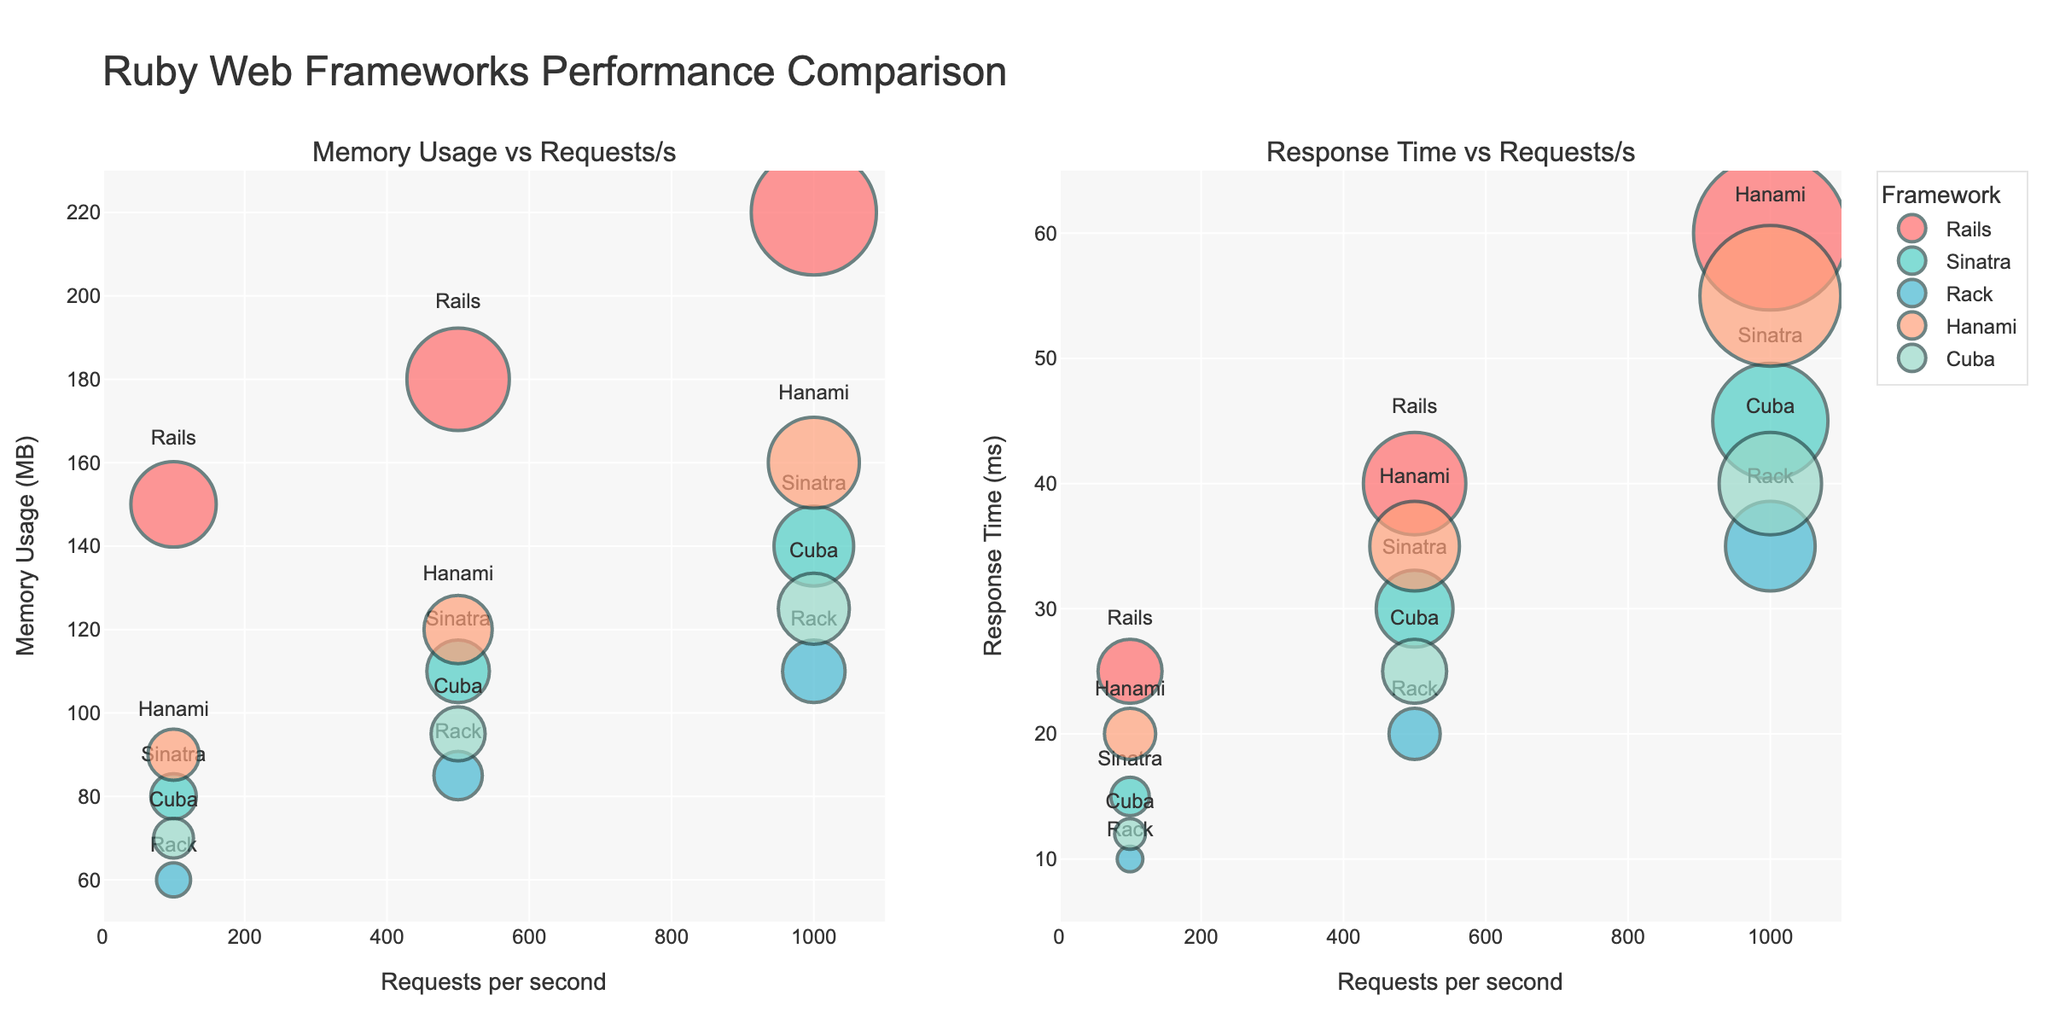Which framework has the highest memory usage at 1000 requests per second? By looking at the subplot titled "Memory Usage vs Requests/s", we can observe that the Rails framework has the highest memory usage of 220 MB at 1000 requests per second.
Answer: Rails Which framework has the lowest response time at 500 requests per second? Referring to the subplot titled "Response Time vs Requests/s", we can see that the Rack framework has the lowest response time of 20 ms at 500 requests per second.
Answer: Rack What is the memory difference between Rails and Sinatra at 1000 requests per second? In the "Memory Usage vs Requests/s" subplot, Rails has a memory usage of 220 MB and Sinatra has 140 MB at 1000 requests per second. The difference is 220 - 140 = 80 MB.
Answer: 80 MB Which framework shows the highest increase in memory usage as the requests per second increase from 100 to 1000? To determine the highest increase, we should calculate the memory usage difference for each framework between 100 and 1000 requests per second. Rails increases by 220 - 150 = 70 MB, Sinatra increases by 140 - 80 = 60 MB, Rack increases by 110 - 60 = 50 MB, Hanami increases by 160 - 90 = 70 MB, and Cuba increases by 125 - 70 = 55 MB. Both Rails and Hanami show the highest increase of 70 MB.
Answer: Rails and Hanami Which framework has a more substantial memory usage increase between 500 and 1000 requests, Rails or Cuba? At 500 requests, Rails uses 180 MB and Cuba 95 MB. At 1000 requests, Rails uses 220 MB and Cuba 125 MB. The increase for Rails is 220 - 180 = 40 MB, and for Cuba, it is 125 - 95 = 30 MB. Rails has a more substantial increase.
Answer: Rails How does Hanami's memory usage at 500 and 1000 requests compare to Rack's memory usage at the same request levels? At 500 requests per second, Hanami's memory usage is 120 MB while Rack's is 85 MB, so Hanami uses 35 MB more. At 1000 requests per second, Hanami's memory usage is 160 MB and Rack's is 110 MB, so Hanami uses 50 MB more.
Answer: Hanami uses 35 MB more at 500 requests and 50 MB more at 1000 requests What's the average response time for Cuba across the given request loads? The response times for Cuba are 12 ms, 25 ms, and 40 ms. The average is calculated as (12 + 25 + 40) / 3 = 77 / 3 ≈ 25.67 ms.
Answer: 25.67 ms How many unique web frameworks are compared in the figure? The figure displays multiple web frameworks, each visually distinct in the bubble charts. By analyzing the legend and plot annotations, we can identify five unique frameworks: Rails, Sinatra, Rack, Hanami, and Cuba.
Answer: 5 What is the total memory usage across all frameworks at 1000 requests per second? Summing up the memory usages from the subplot for each framework: Rails 220 MB, Sinatra 140 MB, Rack 110 MB, Hanami 160 MB, and Cuba 125 MB. Total memory usage is 220 + 140 + 110 + 160 + 125 = 755 MB.
Answer: 755 MB 